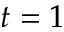Convert formula to latex. <formula><loc_0><loc_0><loc_500><loc_500>t = 1</formula> 